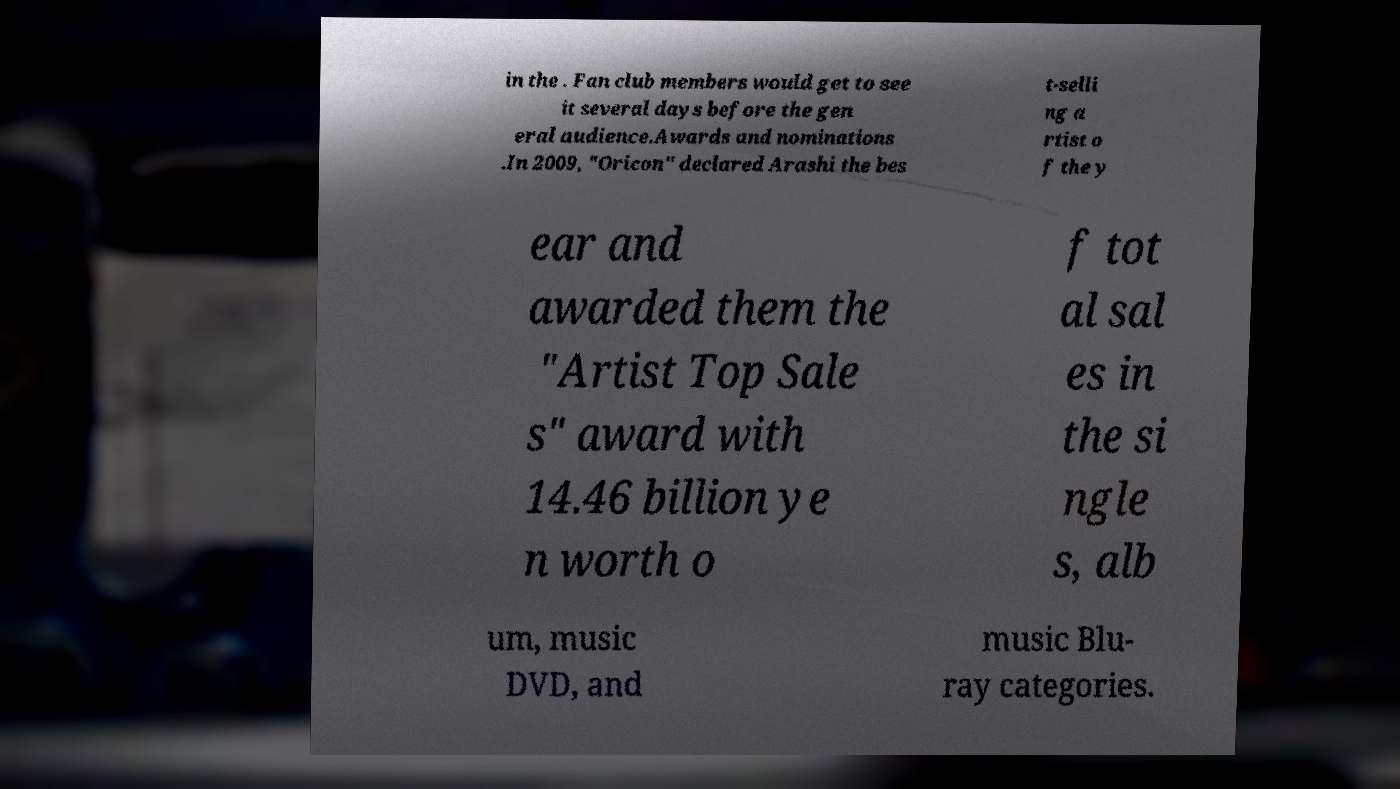I need the written content from this picture converted into text. Can you do that? in the . Fan club members would get to see it several days before the gen eral audience.Awards and nominations .In 2009, "Oricon" declared Arashi the bes t-selli ng a rtist o f the y ear and awarded them the "Artist Top Sale s" award with 14.46 billion ye n worth o f tot al sal es in the si ngle s, alb um, music DVD, and music Blu- ray categories. 